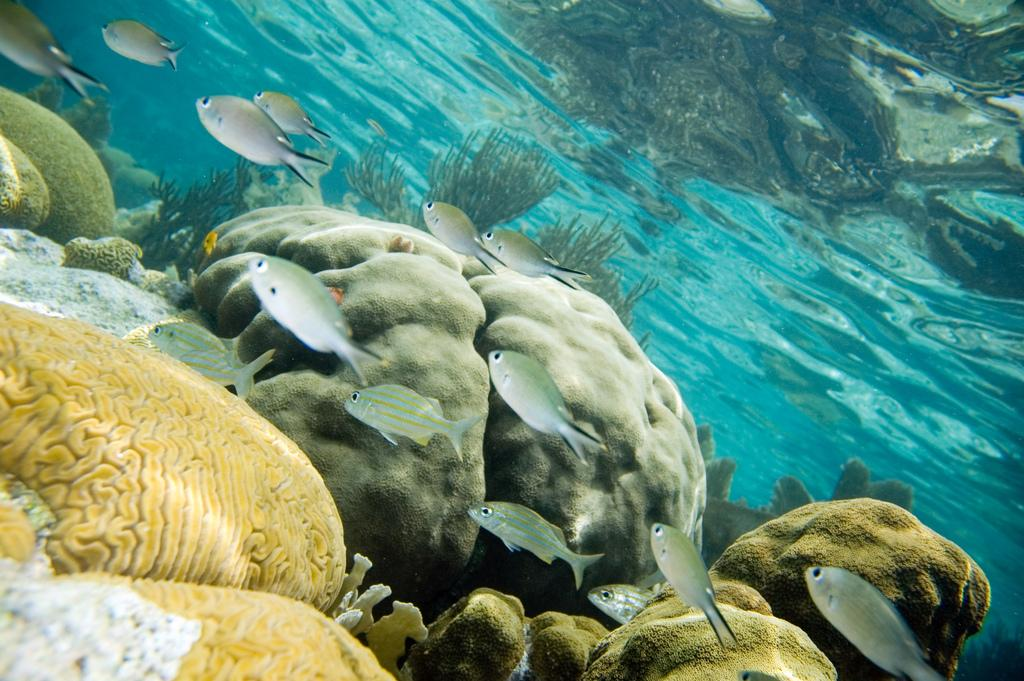What type of animals can be seen in the image? There are fishes in the water. What other elements can be found in the image besides the fishes? There are rocks and grass in the image. What advice does the girl give about the stew in the image? There is no girl or stew present in the image, so no advice can be given. 